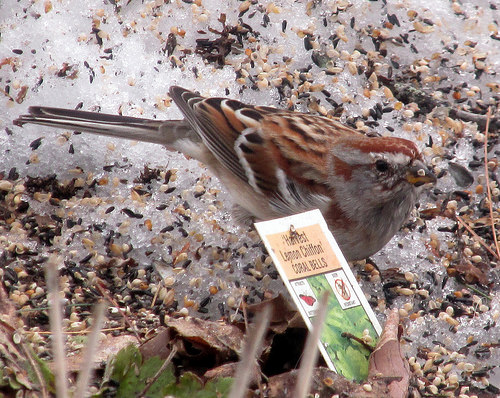<image>
Can you confirm if the paper is next to the bird? Yes. The paper is positioned adjacent to the bird, located nearby in the same general area. 